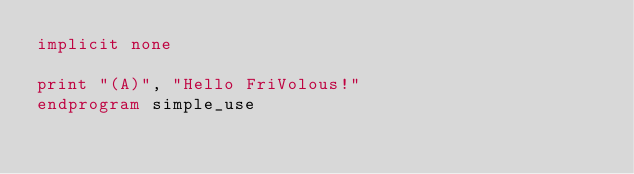<code> <loc_0><loc_0><loc_500><loc_500><_FORTRAN_>implicit none

print "(A)", "Hello FriVolous!"
endprogram simple_use
</code> 